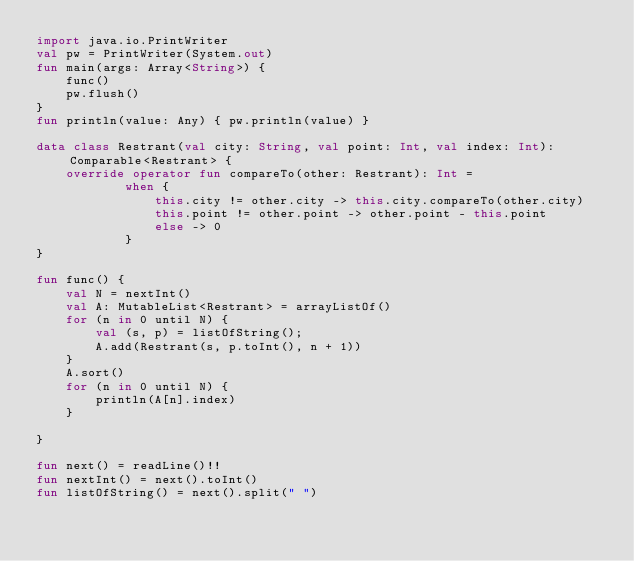Convert code to text. <code><loc_0><loc_0><loc_500><loc_500><_Kotlin_>import java.io.PrintWriter
val pw = PrintWriter(System.out)
fun main(args: Array<String>) {
    func()
    pw.flush()
}
fun println(value: Any) { pw.println(value) }

data class Restrant(val city: String, val point: Int, val index: Int): Comparable<Restrant> {
    override operator fun compareTo(other: Restrant): Int =
            when {
                this.city != other.city -> this.city.compareTo(other.city)
                this.point != other.point -> other.point - this.point
                else -> 0
            }
}

fun func() {
    val N = nextInt()
    val A: MutableList<Restrant> = arrayListOf()
    for (n in 0 until N) {
        val (s, p) = listOfString();
        A.add(Restrant(s, p.toInt(), n + 1))
    }
    A.sort()
    for (n in 0 until N) {
        println(A[n].index)
    }

}

fun next() = readLine()!!
fun nextInt() = next().toInt()
fun listOfString() = next().split(" ")
</code> 